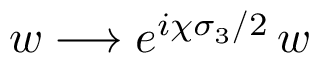<formula> <loc_0><loc_0><loc_500><loc_500>w \longrightarrow e ^ { i \chi \sigma _ { 3 } / 2 } \, w</formula> 